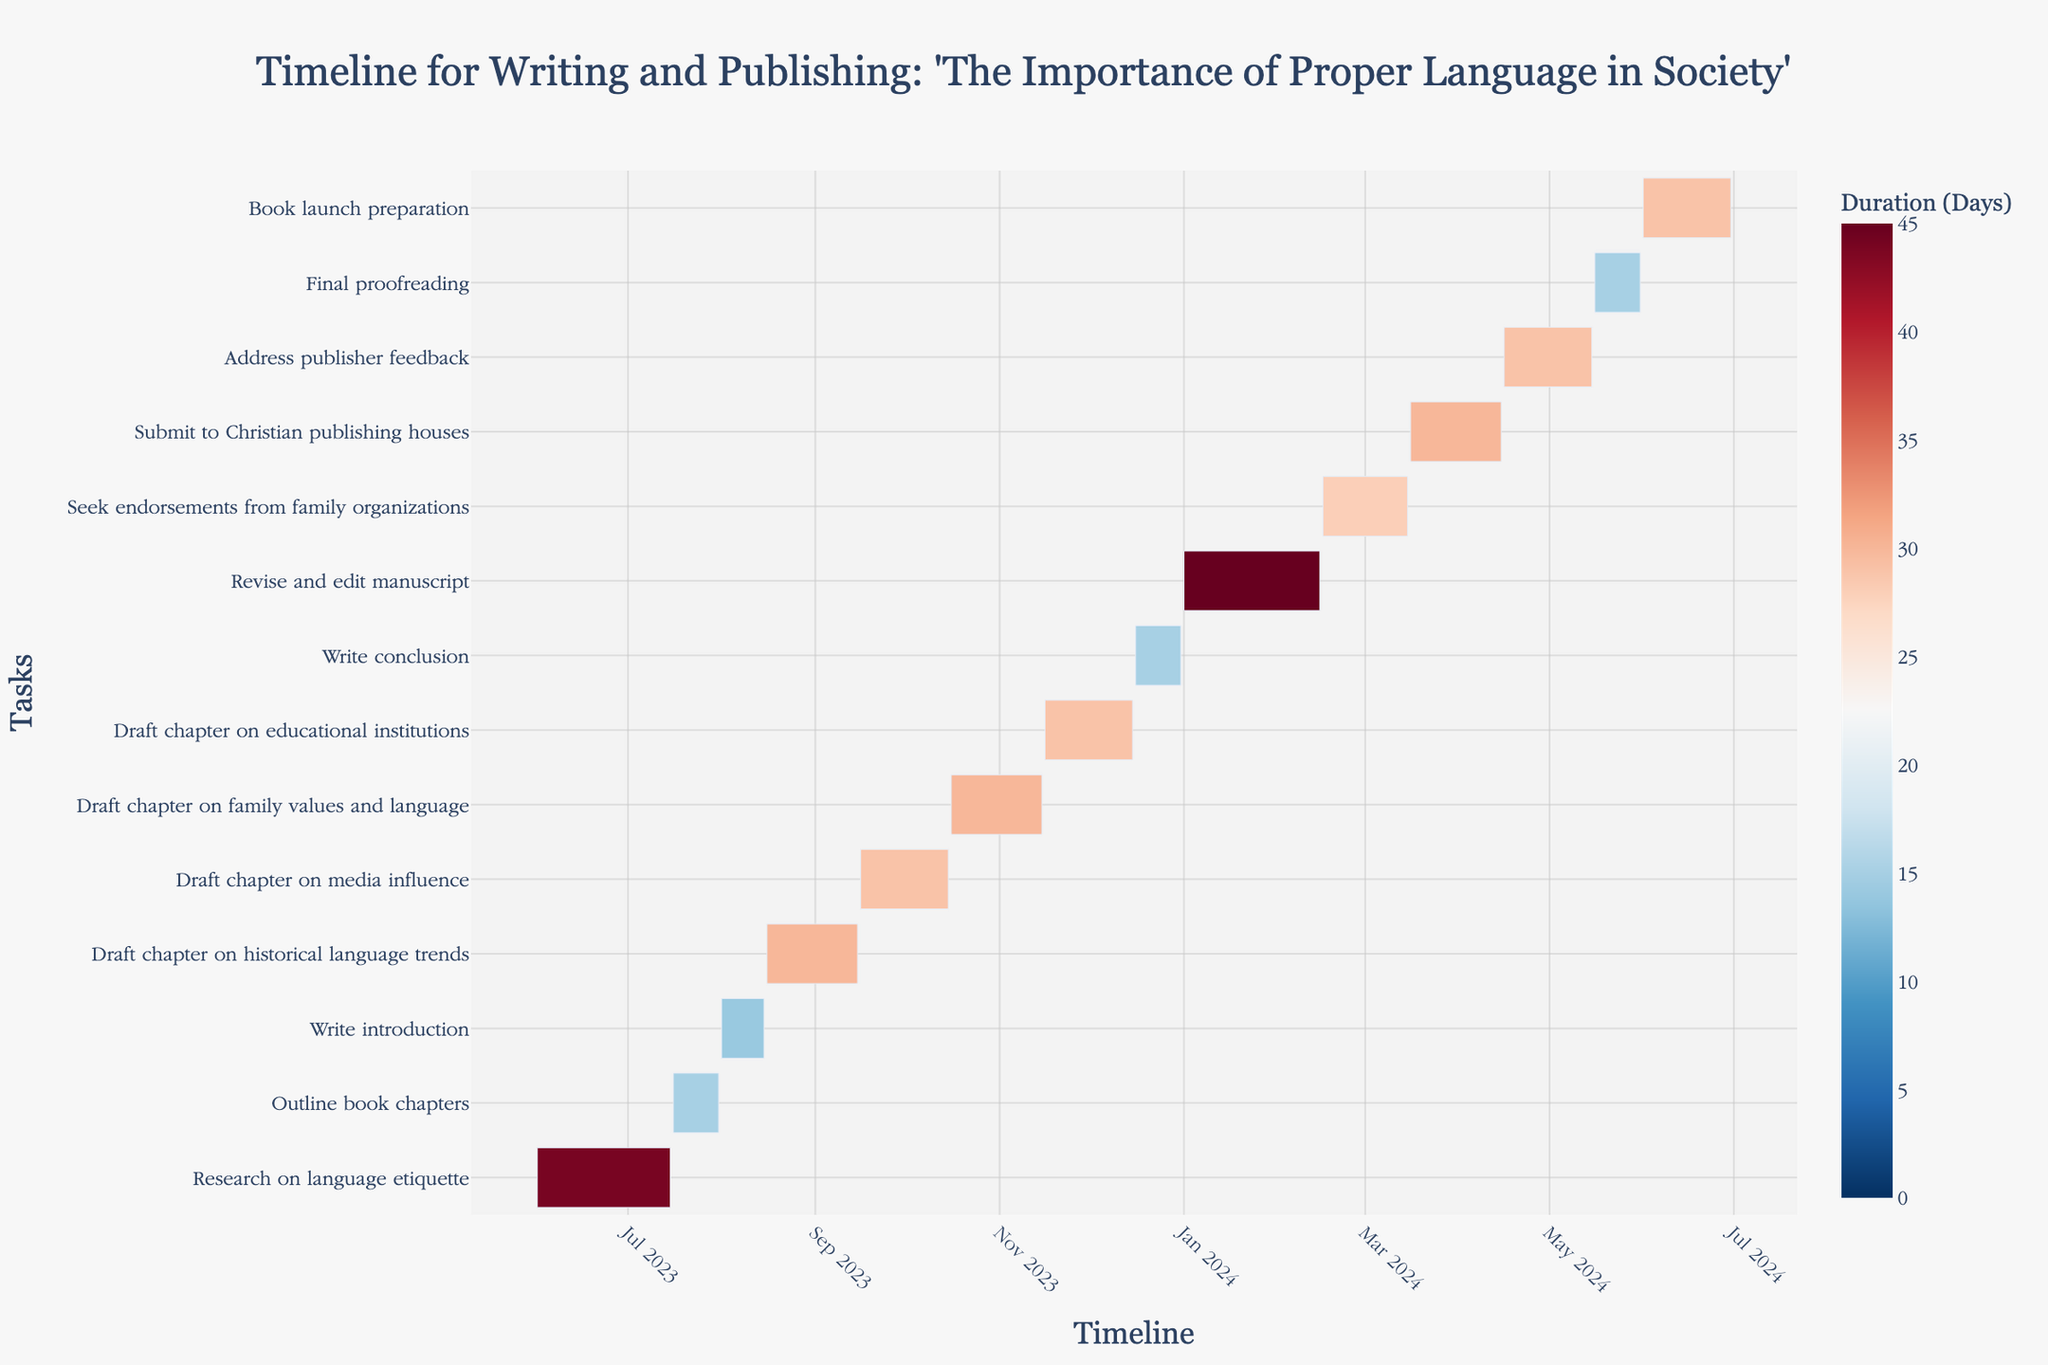What's the title of the Gantt chart? The title of the Gantt chart is usually in a prominent position at the top of the chart.
Answer: Timeline for Writing and Publishing: 'The Importance of Proper Language in Society' How long is the task "Write introduction" scheduled to take? Find the "Write introduction" task row, then look at the timeline to determine the duration between the start and end dates.
Answer: 15 days What is the first task in the timeline, and when does it start? Look at the first task listed at the top of the Gantt chart and check the start date for that task.
Answer: Research on language etiquette, 2023-06-01 Which task has the longest duration? Compare the duration of all tasks by looking at each task's timeline and identify which bar is the longest.
Answer: Research on language etiquette How many tasks are scheduled to take place after December 2023? Identify tasks with start dates in the Gantt chart positioned after December 2023 and count them.
Answer: 6 tasks Which tasks overlap in October 2023? Look at the timeline section corresponding to October 2023 and check which tasks have bars that overlap in this period.
Answer: Draft chapter on media influence and Draft chapter on family values and language How long does it take from the start of "Seek endorsements from family organizations" to the end of "Book launch preparation"? Calculate the duration from February 16, 2024 (start of seeking endorsements) to June 30, 2024 (end of book launch preparation).
Answer: Approximately 135 days What tasks are scheduled to start in 2024? Identify tasks that have a start date in the Gantt chart with the year 2024.
Answer: Revise and edit manuscript, Seek endorsements from family organizations, Submit to Christian publishing houses, Address publisher feedback, Final proofreading, Book launch preparation During which month does the task "Book launch preparation" take place? Look at the start and end dates of the "Book launch preparation" task to determine the month they fall into.
Answer: June 2024 What are the tasks that involve drafting chapters, and how long does it take to complete all of them? Identify tasks with "Draft chapter on" in their names and sum their durations.
Answer: Historical language trends (30 days), Media influence (30 days), Family values and language (30 days), Educational institutions (30 days). Total = 120 days 